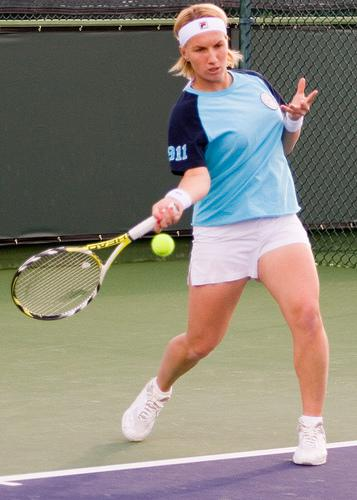Question: where was this photo taken?
Choices:
A. At baseball game.
B. At the court.
C. Along he street.
D. On a tennis court.
Answer with the letter. Answer: D Question: what is she doing?
Choices:
A. Reading.
B. Watching Tv.
C. Running.
D. Playing.
Answer with the letter. Answer: D Question: what is she?
Choices:
A. Ugly.
B. Fat.
C. Old.
D. A player.
Answer with the letter. Answer: D Question: what sport is this?
Choices:
A. Baseball.
B. Lawn tennis.
C. Football.
D. Basketball.
Answer with the letter. Answer: B Question: why is she stretching?
Choices:
A. Warm Up.
B. To life weights.
C. Muscle Cramp.
D. To hit the ball.
Answer with the letter. Answer: D Question: who is she?
Choices:
A. The queen.
B. A woman.
C. Mom.
D. Professor.
Answer with the letter. Answer: B Question: when was this?
Choices:
A. Daytime.
B. Christmas.
C. Bedtime.
D. Last year.
Answer with the letter. Answer: A 